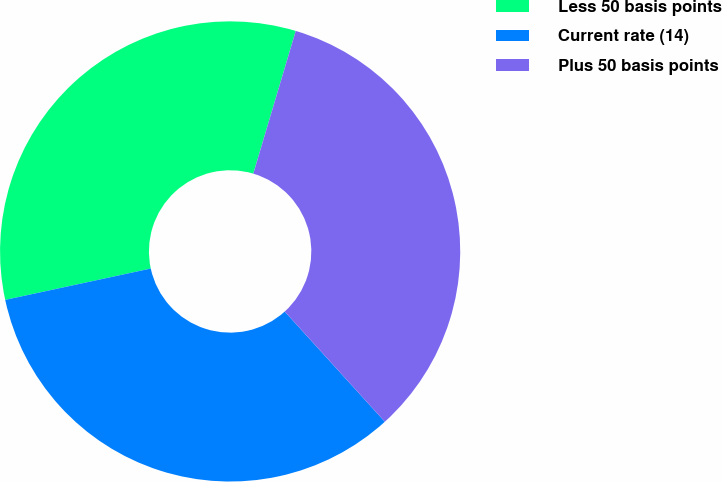<chart> <loc_0><loc_0><loc_500><loc_500><pie_chart><fcel>Less 50 basis points<fcel>Current rate (14)<fcel>Plus 50 basis points<nl><fcel>32.98%<fcel>33.36%<fcel>33.66%<nl></chart> 